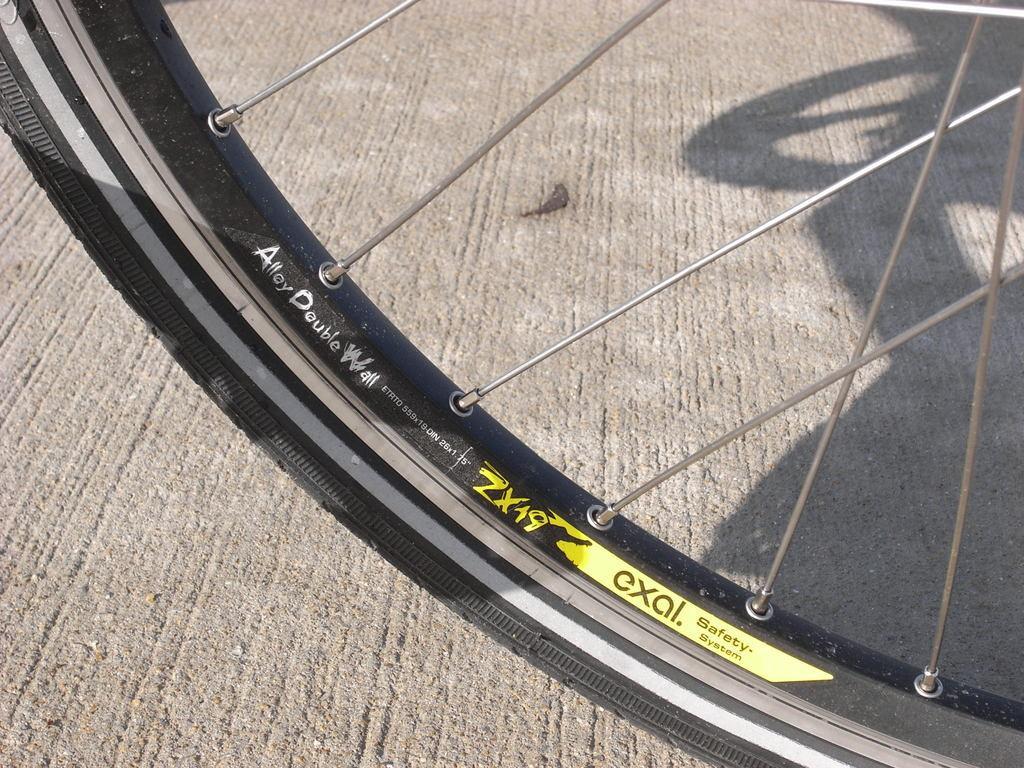Please provide a concise description of this image. In this image we can see a wheel of a bicycle, we can also see spokes on it. 